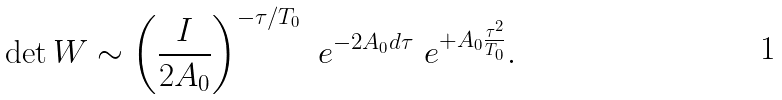<formula> <loc_0><loc_0><loc_500><loc_500>\det W \sim \left ( \frac { I } { 2 A _ { 0 } } \right ) ^ { - \tau / T _ { 0 } } { \ e } ^ { - 2 A _ { 0 } d \tau } { \ e } ^ { + A _ { 0 } \frac { \tau ^ { 2 } } { T _ { 0 } } } .</formula> 